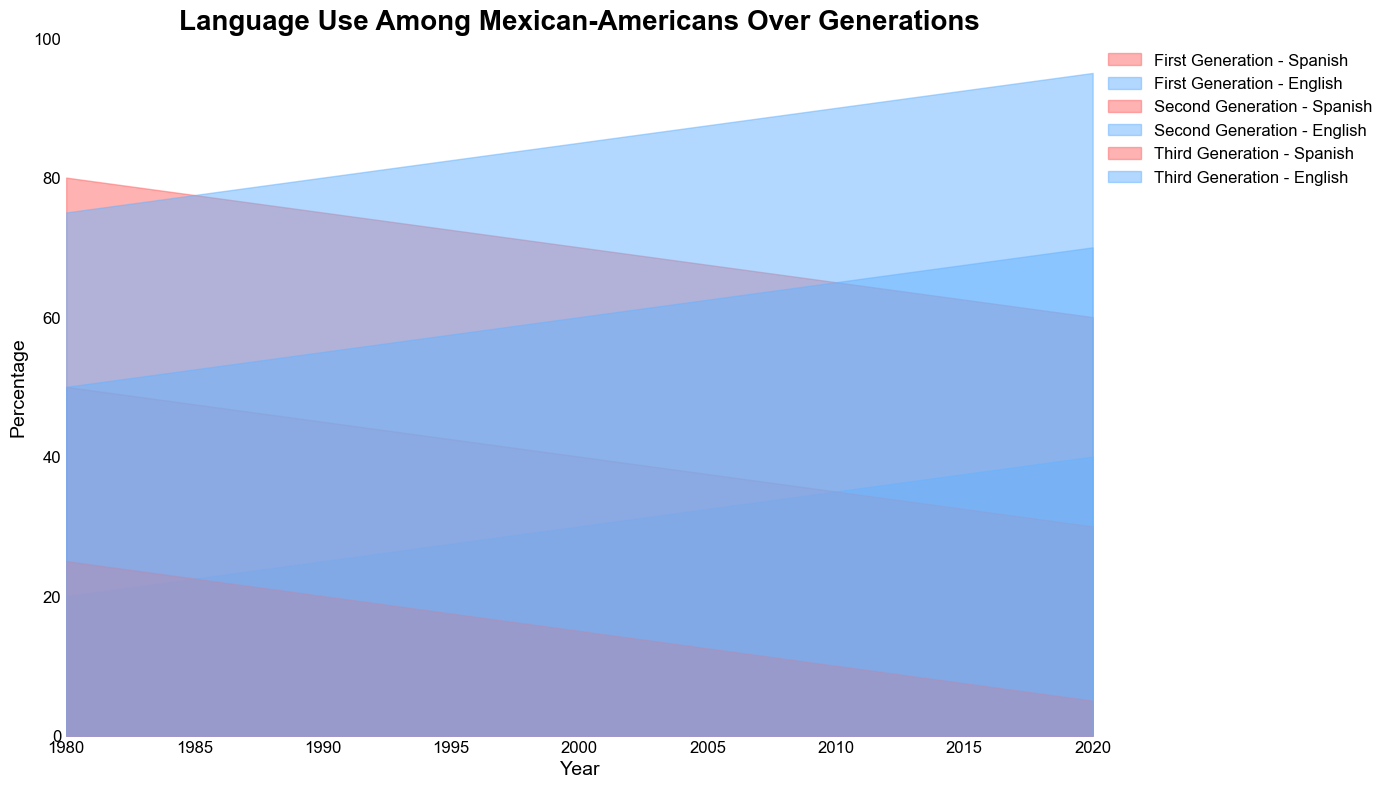What is the overall trend in Spanish language usage for the second generation from 1980 to 2020? The Spanish language usage for the second generation shows a decreasing trend from 50% in 1980 to 30% in 2020. This can be inferred by observing how the area representing Spanish language declines over the years for the second generation.
Answer: Decreasing What is the percentage difference in Spanish language usage between the first and third generations in 2020? In 2020, the first generation's Spanish language usage is at 60%, while the third generation's usage is at 5%. The difference is calculated by subtracting the third generation's percentage from the first generation's percentage (60% - 5%).
Answer: 55% Which generation shows the greatest shift towards English usage from 1980 to 2020? The third generation shows the most significant shift towards English usage. In 1980, English usage was at 75%, and by 2020, it increased to 95%, a 20% increase. This can be observed by comparing the changes over the years for each generation.
Answer: Third generation In which year did the first and second generations have the same combined percentage for Spanish and English language usage? The combined percentage for each language should always be 100% for every generation in each year, as every generation's language usage is split between Spanish and English. Therefore, in every available year, the combined percentage is the same.
Answer: All years What visual attribute indicates that English is more commonly used than Spanish among the third generation in 2020? In 2020, the third generation's English usage is represented by a larger area (95%) compared to the much smaller area for Spanish (5%). The relative height of the areas clearly shows that English is more commonly used.
Answer: Larger area for English By how much did English usage increase from 1980 to 2020 in the second generation? English usage in the second generation increased from 50% in 1980 to 70% in 2020. The increase can be calculated by subtracting the initial percentage from the final percentage (70% - 50%).
Answer: 20% How does the rate of decline in Spanish usage compare between the first and second generations from 1980 to 2020? For the first generation, Spanish usage declined from 80% in 1980 to 60% in 2020, a 20% decrease. For the second generation, it declined from 50% to 30%, also a 20% decrease. Both generations experienced the same rate of decline in Spanish usage over this period.
Answer: Same rate of decline In 2010, which generation had the highest English usage, and what was the percentage? In 2010, the third generation had the highest English usage at 90%. This can be seen by comparing the heights of the areas representing English usage for each generation.
Answer: Third generation, 90% 